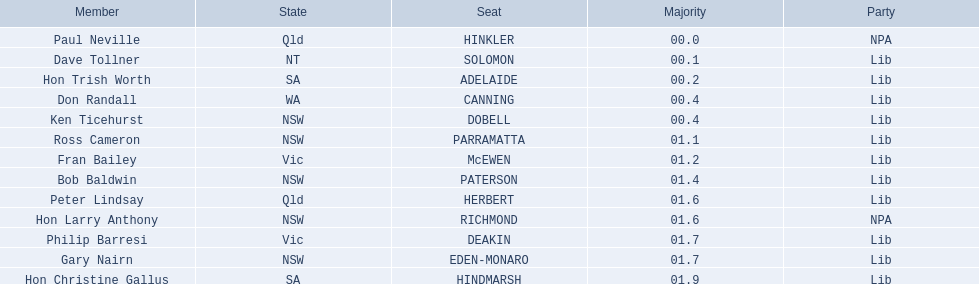Who are all the lib party members? Dave Tollner, Hon Trish Worth, Don Randall, Ken Ticehurst, Ross Cameron, Fran Bailey, Bob Baldwin, Peter Lindsay, Philip Barresi, Gary Nairn, Hon Christine Gallus. What lib party members are in sa? Hon Trish Worth, Hon Christine Gallus. What is the highest difference in majority between members in sa? 01.9. 